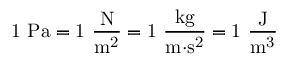Convert formula to latex. <formula><loc_0><loc_0><loc_500><loc_500>{ 1 P a = 1 { \frac { N } { m ^ { 2 } } } = 1 { \frac { k g } { m { \cdot } s ^ { 2 } } } = 1 { \frac { J } { m ^ { 3 } } } }</formula> 